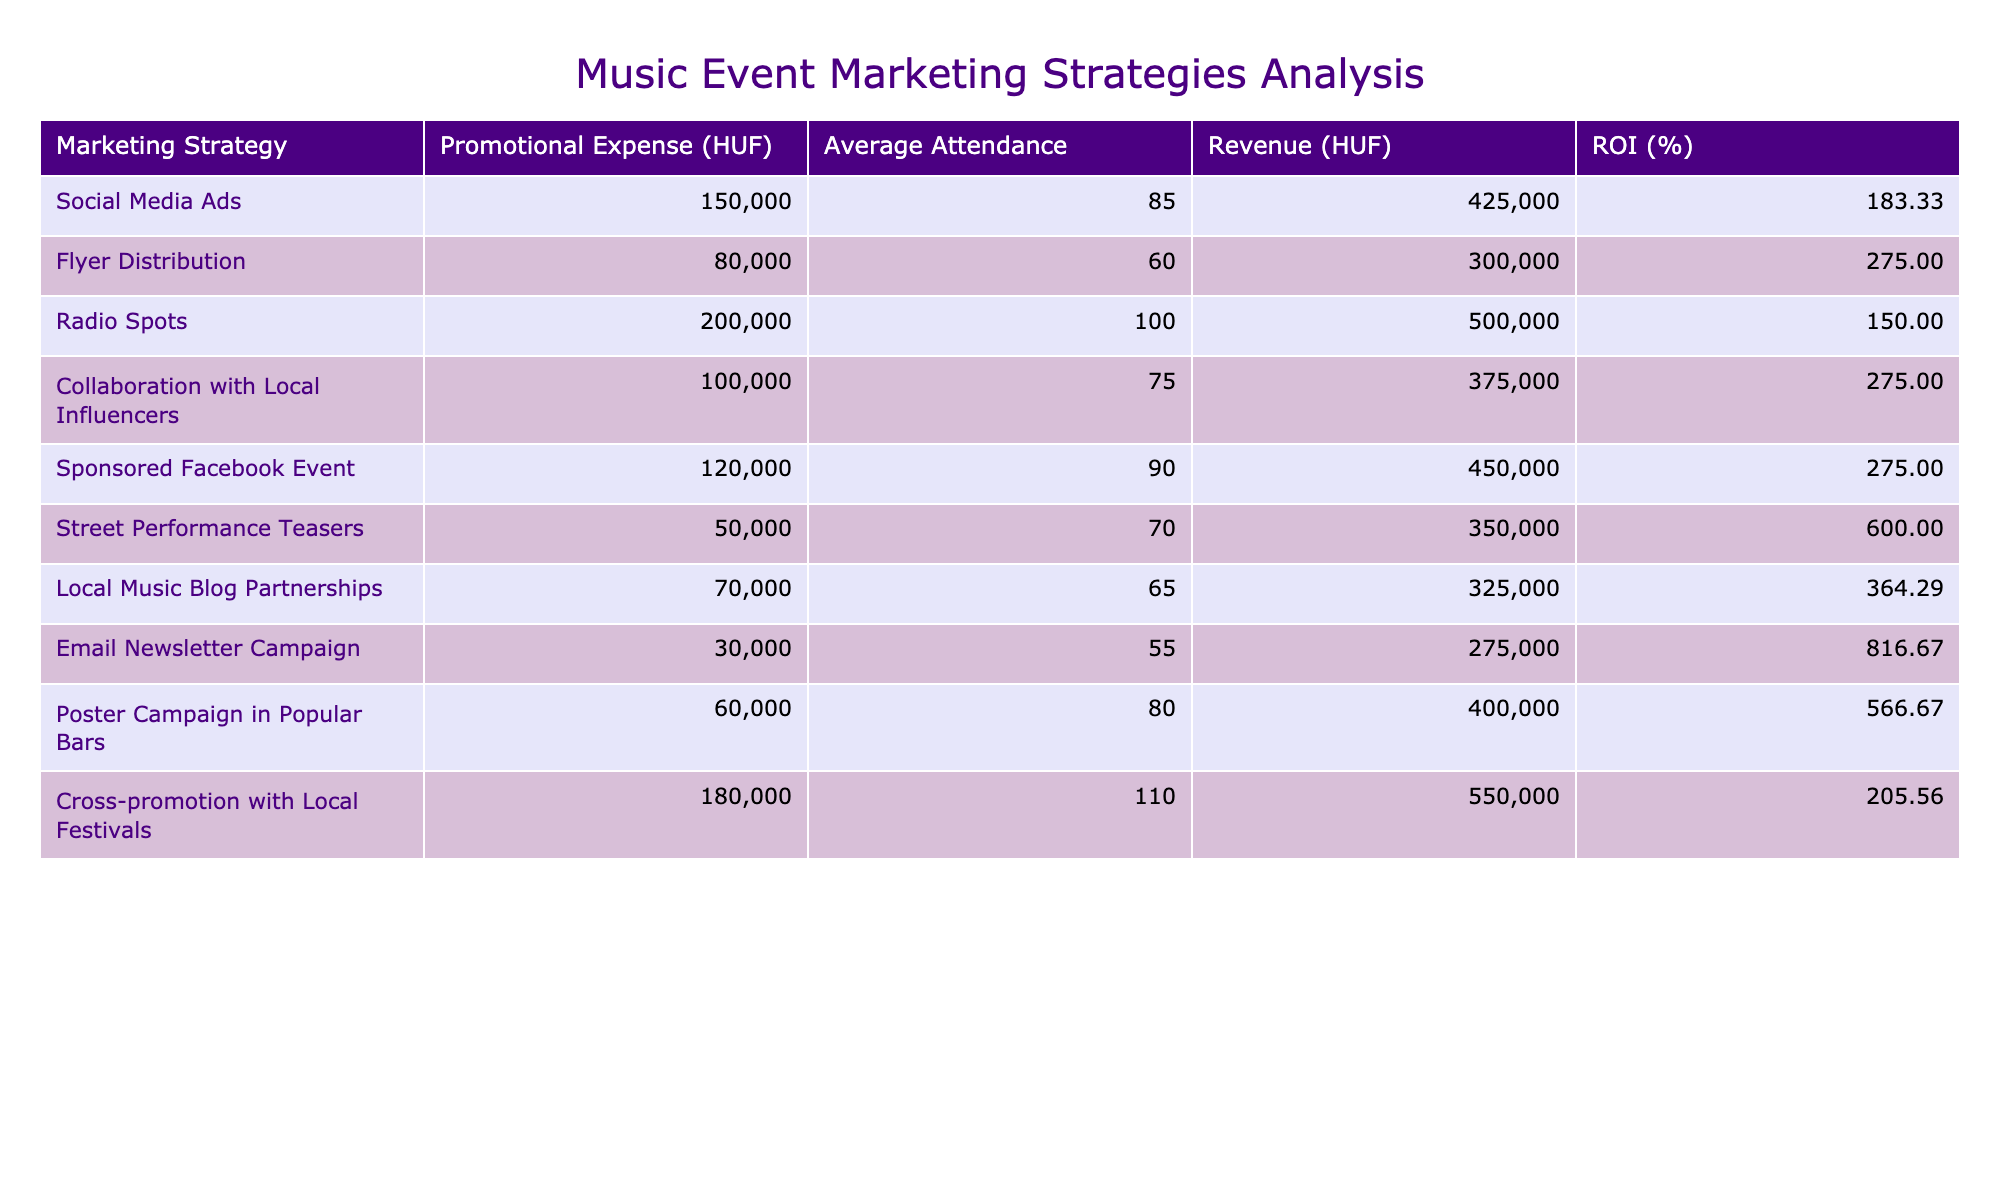What is the promotional expense for the "Street Performance Teasers"? The table shows that the promotional expense for "Street Performance Teasers" is listed under the column for Promotional Expense, which is 50,000 HUF.
Answer: 50,000 HUF Which marketing strategy had the highest return on investment (ROI)? By comparing the ROI percentages listed in the table, "Email Newsletter Campaign" has the highest ROI at 816.67%.
Answer: Email Newsletter Campaign What is the average attendance across all marketing strategies? To find the average attendance, I sum all attendance values (85 + 60 + 100 + 75 + 90 + 70 + 65 + 55 + 80 + 110 = 820) and divide by 10, resulting in an average attendance of 82.
Answer: 82 Did "Collaboration with Local Influencers" have a higher ROI than "Radio Spots"? The ROI for "Collaboration with Local Influencers" is 275.00%, while "Radio Spots" has an ROI of 150.00%. Since 275.00% is greater than 150.00%, the answer is yes.
Answer: Yes What is the total revenue generated from "Flyer Distribution" and "Poster Campaign in Popular Bars"? I take the revenue from both strategies: "Flyer Distribution" is 300,000 HUF and "Poster Campaign in Popular Bars" is 400,000 HUF. The total revenue is 300,000 + 400,000 = 700,000 HUF.
Answer: 700,000 HUF Which marketing strategy had the lowest promotional expense? By examining the promotional expenses, "Email Newsletter Campaign" has the lowest expense at 30,000 HUF compared to other strategies.
Answer: Email Newsletter Campaign What is the difference in ROI between "Social Media Ads" and "Cross-promotion with Local Festivals"? The ROI for "Social Media Ads" is 183.33% and "Cross-promotion with Local Festivals" is 205.56%. The difference is 205.56% - 183.33% = 22.23%.
Answer: 22.23% Is the average revenue higher for strategies that cost more than 150,000 HUF? Strategies costing more than 150,000 HUF are: Radio Spots, Cross-promotion with Local Festivals, and Social Media Ads with revenues of 500,000 HUF, 550,000 HUF, and 425,000 HUF, respectively. Calculating the average yields (500,000 + 550,000 + 425,000) / 3 = 491,667 HUF. Comparing this with those costing 150,000 HUF or less indicates they have lower average revenue. Thus, the answer is yes, they are higher.
Answer: Yes What is the total promotional expense for all strategies combined? By adding all promotional expenses together (150,000 + 80,000 + 200,000 + 100,000 + 120,000 + 50,000 + 70,000 + 30,000 + 60,000 + 180,000), the total promotional expense amounts to 1,090,000 HUF.
Answer: 1,090,000 HUF 